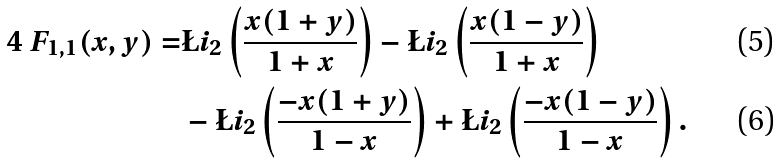<formula> <loc_0><loc_0><loc_500><loc_500>4 \ F _ { 1 , 1 } ( x , y ) = & \L i _ { 2 } \left ( \frac { x ( 1 + y ) } { 1 + x } \right ) - \L i _ { 2 } \left ( \frac { x ( 1 - y ) } { 1 + x } \right ) \\ & - \L i _ { 2 } \left ( \frac { - x ( 1 + y ) } { 1 - x } \right ) + \L i _ { 2 } \left ( \frac { - x ( 1 - y ) } { 1 - x } \right ) .</formula> 